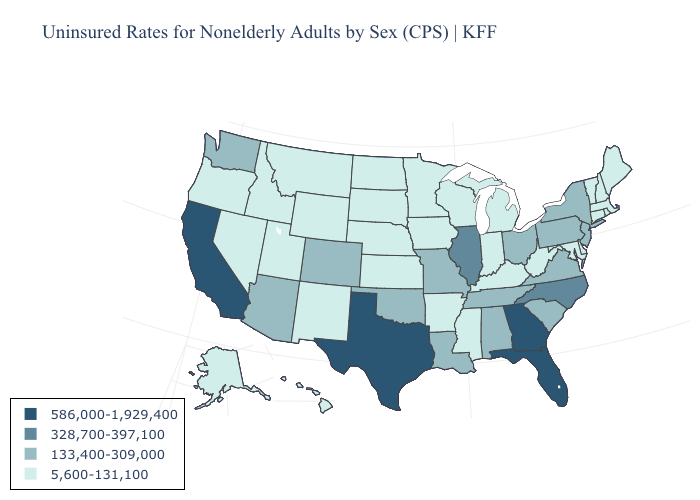Which states have the highest value in the USA?
Keep it brief. California, Florida, Georgia, Texas. What is the value of Alaska?
Short answer required. 5,600-131,100. Name the states that have a value in the range 586,000-1,929,400?
Be succinct. California, Florida, Georgia, Texas. Among the states that border Missouri , does Illinois have the highest value?
Concise answer only. Yes. Which states have the lowest value in the South?
Quick response, please. Arkansas, Delaware, Kentucky, Maryland, Mississippi, West Virginia. Which states hav the highest value in the MidWest?
Keep it brief. Illinois. Name the states that have a value in the range 328,700-397,100?
Be succinct. Illinois, North Carolina. Does Delaware have a lower value than Minnesota?
Short answer required. No. What is the highest value in the South ?
Keep it brief. 586,000-1,929,400. What is the value of Pennsylvania?
Quick response, please. 133,400-309,000. Name the states that have a value in the range 133,400-309,000?
Short answer required. Alabama, Arizona, Colorado, Louisiana, Missouri, New Jersey, New York, Ohio, Oklahoma, Pennsylvania, South Carolina, Tennessee, Virginia, Washington. Name the states that have a value in the range 133,400-309,000?
Keep it brief. Alabama, Arizona, Colorado, Louisiana, Missouri, New Jersey, New York, Ohio, Oklahoma, Pennsylvania, South Carolina, Tennessee, Virginia, Washington. Does New Jersey have the same value as Tennessee?
Concise answer only. Yes. Which states hav the highest value in the South?
Give a very brief answer. Florida, Georgia, Texas. What is the value of Delaware?
Short answer required. 5,600-131,100. 